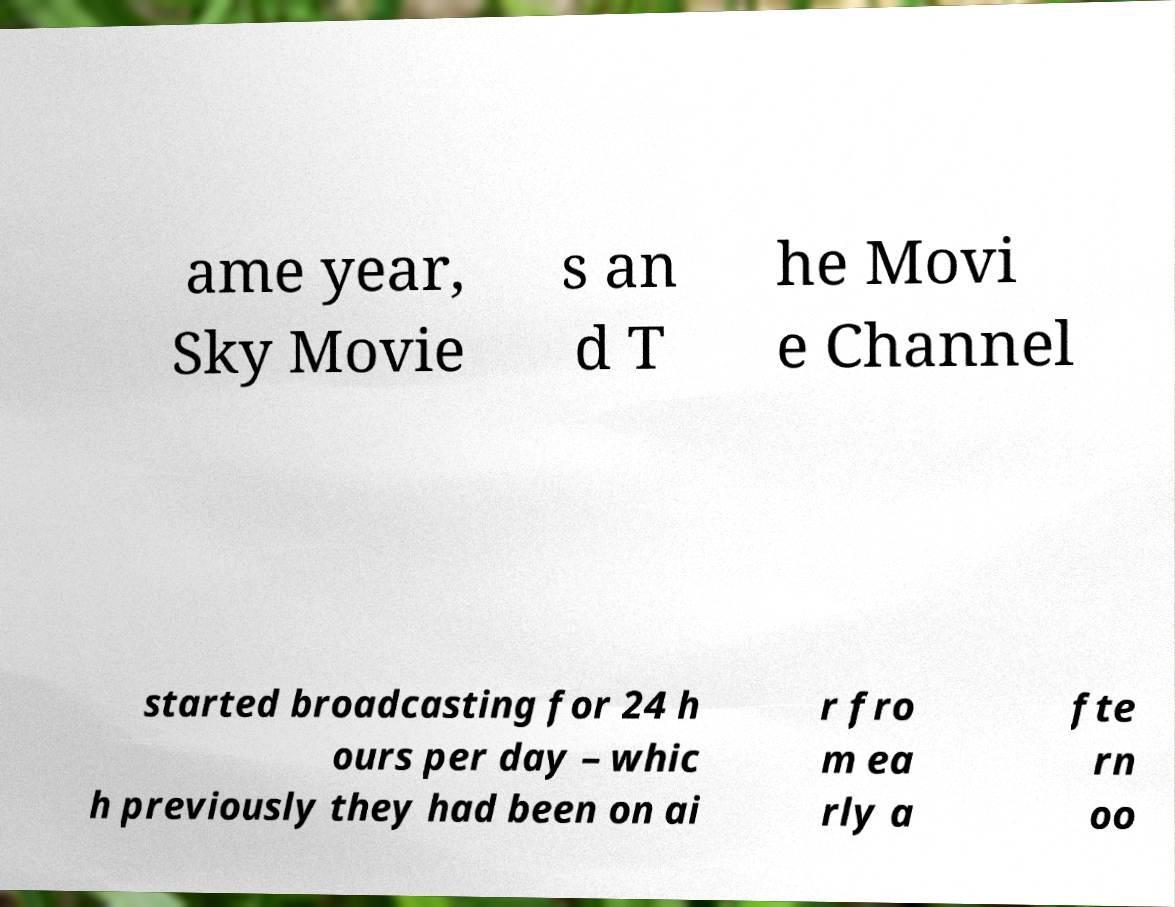What messages or text are displayed in this image? I need them in a readable, typed format. ame year, Sky Movie s an d T he Movi e Channel started broadcasting for 24 h ours per day – whic h previously they had been on ai r fro m ea rly a fte rn oo 